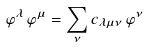Convert formula to latex. <formula><loc_0><loc_0><loc_500><loc_500>\varphi ^ { \lambda } \, \varphi ^ { \mu } = \sum _ { \nu } c _ { \lambda \mu \nu } \, \varphi ^ { \nu }</formula> 